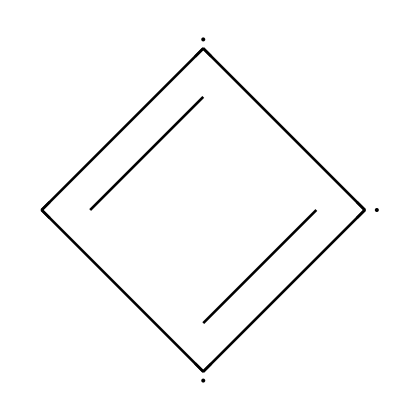What is the number of carbon atoms in this structure? The SMILES notation provides a representation of the atoms in the chemical. In this case, the letter 'C' represents carbon atoms. Counting each 'C', we find there are 6 carbon atoms in total.
Answer: 6 How many double bonds are present in this chemical? Each '=' symbol in the SMILES denotes a double bond. There are 3 '=' symbols in the given SMILES, indicating the presence of 3 double bonds in the structure.
Answer: 3 What is the overall shape of the molecular structure? The structure described shows alternating double and single bonds typical of conjugated systems. This will lead to a planar structure that can be visualized as a hexagonal arrangement of carbon atoms, resembling benzene.
Answer: planar What type of lubricant is this molecule primarily associated with? The structure is composed of carbon, characteristic of graphite, which is known for its lubricating properties due to its layered planar structure allowing easy sliding of layers over each other. This specific structure makes it suited for mechanical lubrication.
Answer: graphite What does the alternating double bond structure suggest about its reactivity? The presence of alternating double bonds indicates that the compound may exhibit resonance, making it more stable and influencing its chemical reactivity to be lower than single bonded compounds. This characteristic is a feature of aromatic compounds typically found in lubricants.
Answer: lower What property of graphite allows it to be used in mechanical pencils? The layered structure and the ability to leave a mark on paper due to the easy sliding of layers gives graphite its primary property for use in mechanical pencils. This allows for smooth writing as the layers of graphite are easily shed when pressure is applied.
Answer: smooth writing 